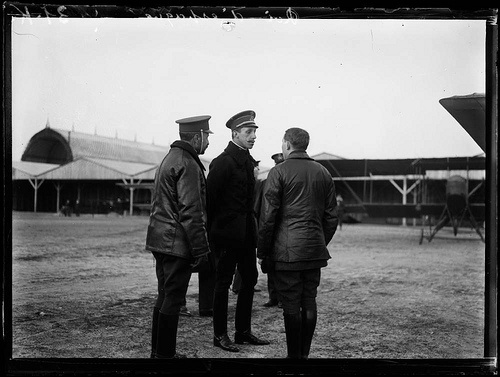Describe the objects in this image and their specific colors. I can see people in black, gray, darkgray, and lightgray tones, airplane in black, gray, darkgray, and lightgray tones, people in black, gray, darkgray, and lightgray tones, and people in black, gray, darkgray, and lightgray tones in this image. 